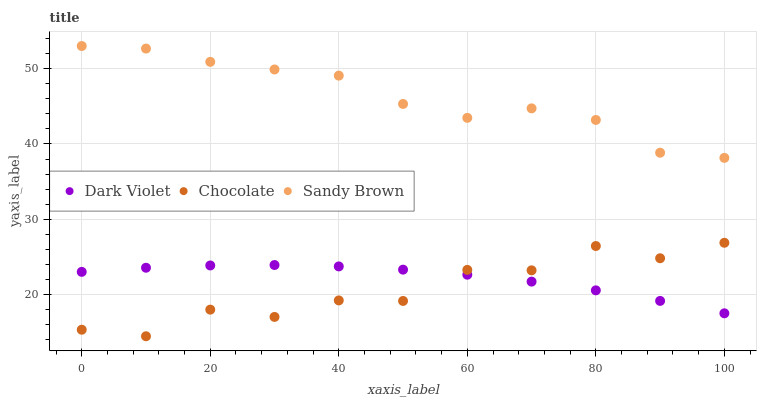Does Chocolate have the minimum area under the curve?
Answer yes or no. Yes. Does Sandy Brown have the maximum area under the curve?
Answer yes or no. Yes. Does Dark Violet have the minimum area under the curve?
Answer yes or no. No. Does Dark Violet have the maximum area under the curve?
Answer yes or no. No. Is Dark Violet the smoothest?
Answer yes or no. Yes. Is Chocolate the roughest?
Answer yes or no. Yes. Is Chocolate the smoothest?
Answer yes or no. No. Is Dark Violet the roughest?
Answer yes or no. No. Does Chocolate have the lowest value?
Answer yes or no. Yes. Does Dark Violet have the lowest value?
Answer yes or no. No. Does Sandy Brown have the highest value?
Answer yes or no. Yes. Does Chocolate have the highest value?
Answer yes or no. No. Is Chocolate less than Sandy Brown?
Answer yes or no. Yes. Is Sandy Brown greater than Dark Violet?
Answer yes or no. Yes. Does Dark Violet intersect Chocolate?
Answer yes or no. Yes. Is Dark Violet less than Chocolate?
Answer yes or no. No. Is Dark Violet greater than Chocolate?
Answer yes or no. No. Does Chocolate intersect Sandy Brown?
Answer yes or no. No. 